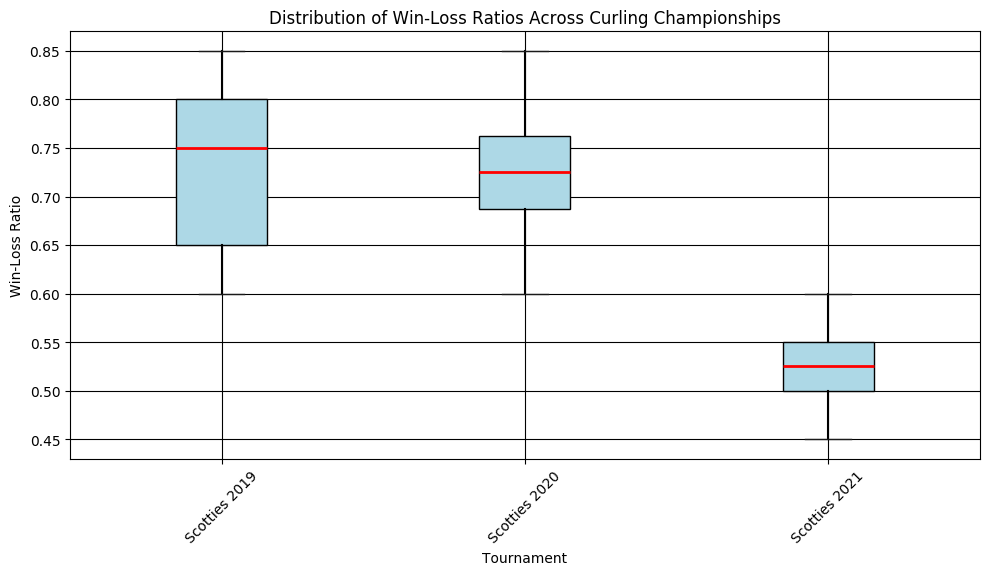What is the median win-loss ratio for Scotties 2019? Identify the median in the box plot for Scotties 2019, which is marked by a red line across the box.
Answer: 0.75 Which tournament has the widest interquartile range (IQR) in win-loss ratios? Measure the distance between the top and bottom edges of the boxes, which represent the IQR, to see which one is widest.
Answer: Scotties 2021 Compare the median win-loss ratios between Scotties 2019 and Scotties 2020. Which one is higher? The median is indicated by the red line. Check the position of the medians in Scotties 2019 and Scotties 2020.
Answer: Scotties 2019 What is the range of win-loss ratios for Scotties 2021? Identify the minimum and maximum values represented by the bottom and top whiskers of the Scotties 2021 boxplot and calculate the difference.
Answer: 0.45 - 0.60 Which tournament has the highest maximum win-loss ratio? Look at the highest points in the whiskers of each boxplot to identify which one is the highest.
Answer: Scotties 2020 Compare the variability of win-loss ratios between Scotties 2019 and Scotties 2021. Which one shows more variability? Evaluate the lengths of the whiskers and the sizes of the boxes (IQR) for both tournaments.
Answer: Scotties 2019 What is the median win-loss ratio difference between Scotties 2020 and Scotties 2021? Identify the median for both Scotties 2020 and Scotties 2021, then subtract the median of Scotties 2021 from that of Scotties 2020.
Answer: 0.20 Based on the visual attributes, which tournament has the smallest overall range of win-loss ratios? The overall range is represented by the length of the entire whisker which can be found by comparing the lengths of all the whiskers for each tournament.
Answer: Scotties 2020 